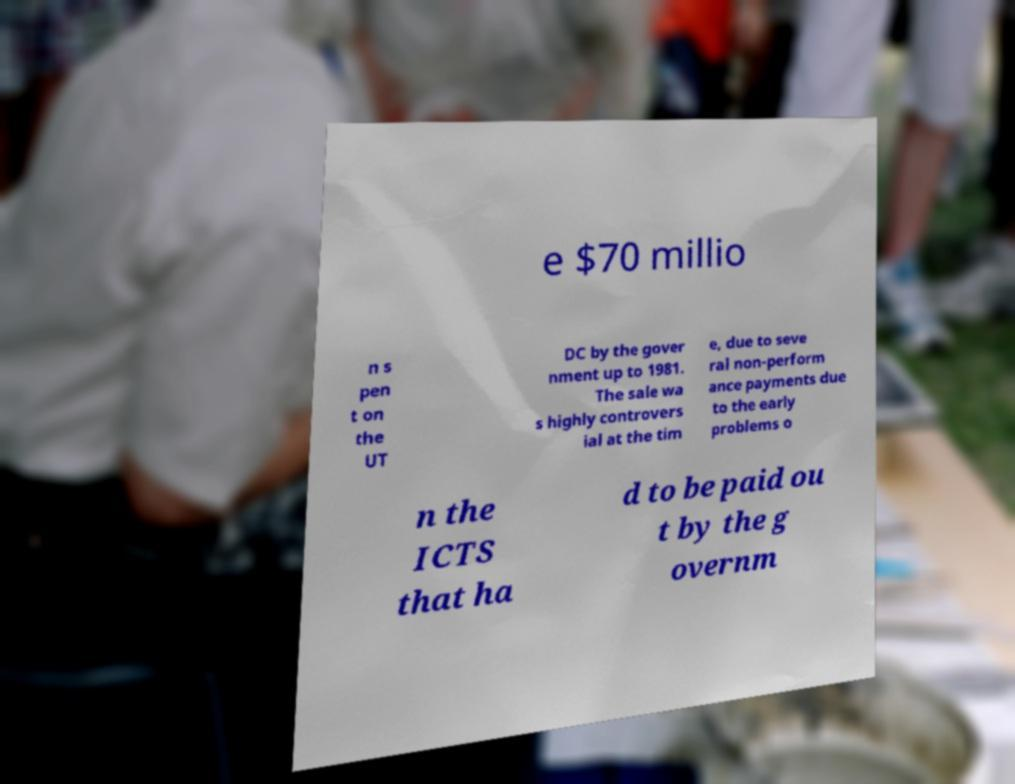I need the written content from this picture converted into text. Can you do that? e $70 millio n s pen t on the UT DC by the gover nment up to 1981. The sale wa s highly controvers ial at the tim e, due to seve ral non-perform ance payments due to the early problems o n the ICTS that ha d to be paid ou t by the g overnm 